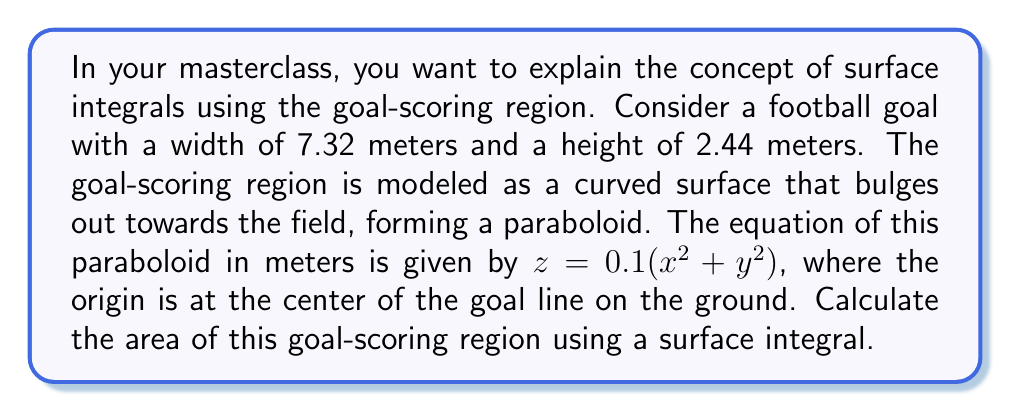What is the answer to this math problem? To solve this problem, we'll follow these steps:

1) The surface is defined by $z = f(x,y) = 0.1(x^2 + y^2)$. The goal dimensions give us the limits: $-3.66 \leq x \leq 3.66$ and $0 \leq y \leq 2.44$.

2) For a surface $z = f(x,y)$, the area is given by the double integral:

   $$A = \iint_S \sqrt{1 + \left(\frac{\partial f}{\partial x}\right)^2 + \left(\frac{\partial f}{\partial y}\right)^2} \, dA$$

3) We need to calculate the partial derivatives:
   
   $\frac{\partial f}{\partial x} = 0.2x$
   $\frac{\partial f}{\partial y} = 0.2y$

4) Substituting these into our integral:

   $$A = \int_{-3.66}^{3.66} \int_0^{2.44} \sqrt{1 + (0.2x)^2 + (0.2y)^2} \, dy \, dx$$

5) This integral is difficult to evaluate analytically, so we'll use numerical integration. Using a computer algebra system or numerical integration tool, we can evaluate this integral.

6) The result of this numerical integration is approximately 18.09 square meters.
Answer: The area of the goal-scoring region is approximately 18.09 square meters. 